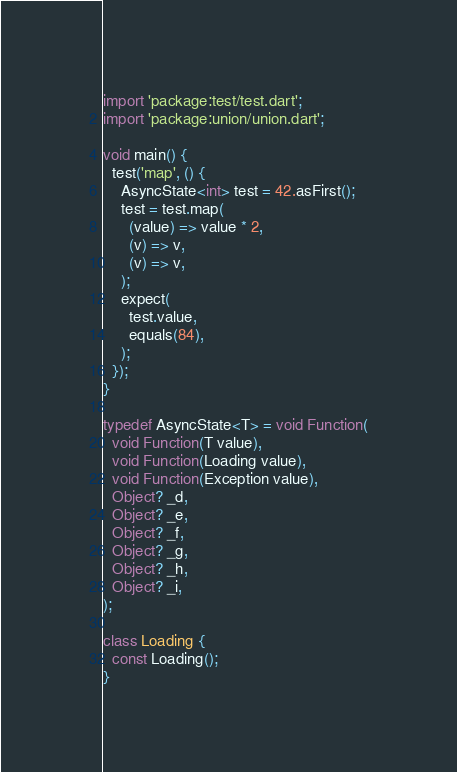Convert code to text. <code><loc_0><loc_0><loc_500><loc_500><_Dart_>import 'package:test/test.dart';
import 'package:union/union.dart';

void main() {
  test('map', () {
    AsyncState<int> test = 42.asFirst();
    test = test.map(
      (value) => value * 2,
      (v) => v,
      (v) => v,
    );
    expect(
      test.value,
      equals(84),
    );
  });
}

typedef AsyncState<T> = void Function(
  void Function(T value),
  void Function(Loading value),
  void Function(Exception value),
  Object? _d,
  Object? _e,
  Object? _f,
  Object? _g,
  Object? _h,
  Object? _i,
);

class Loading {
  const Loading();
}
</code> 